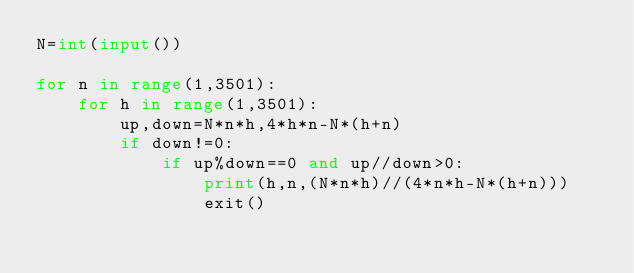Convert code to text. <code><loc_0><loc_0><loc_500><loc_500><_Python_>N=int(input())

for n in range(1,3501):
    for h in range(1,3501):
        up,down=N*n*h,4*h*n-N*(h+n)
        if down!=0:
            if up%down==0 and up//down>0:
                print(h,n,(N*n*h)//(4*n*h-N*(h+n)))
                exit()</code> 